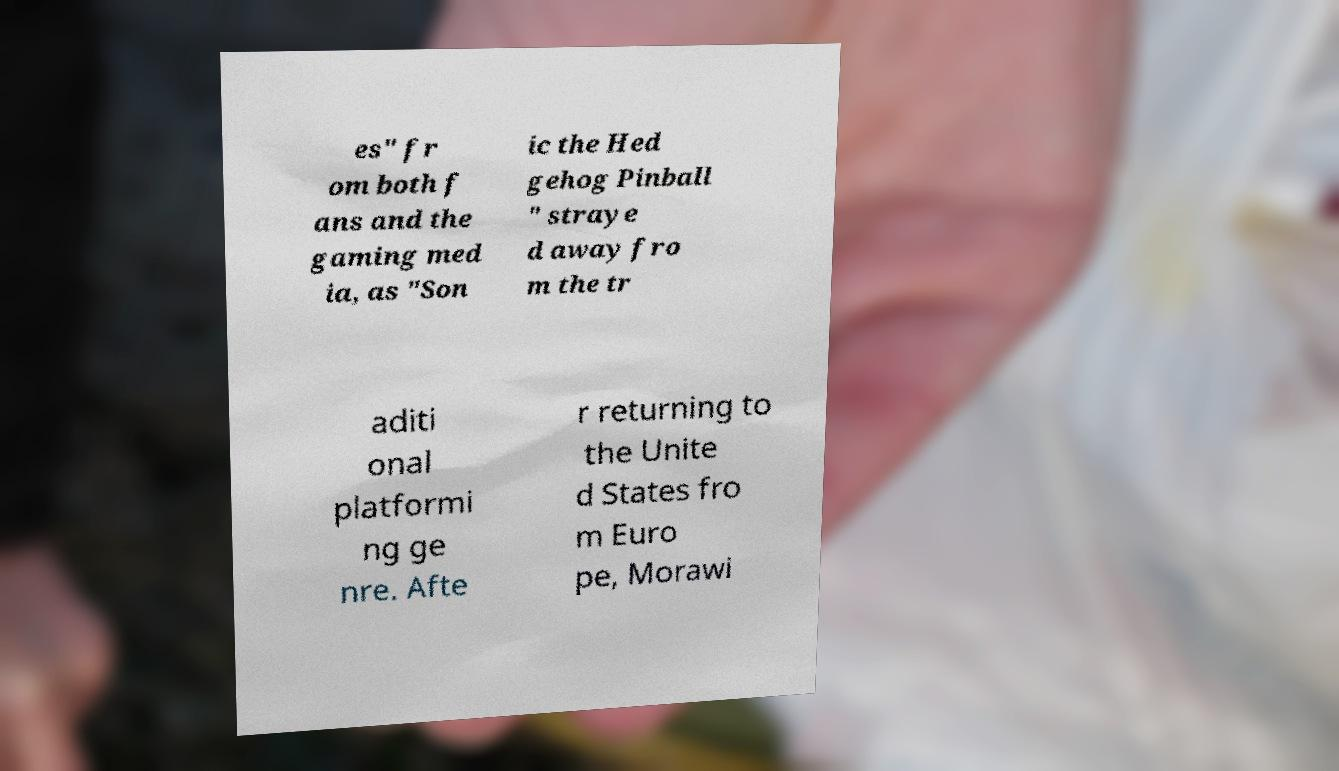There's text embedded in this image that I need extracted. Can you transcribe it verbatim? es" fr om both f ans and the gaming med ia, as "Son ic the Hed gehog Pinball " straye d away fro m the tr aditi onal platformi ng ge nre. Afte r returning to the Unite d States fro m Euro pe, Morawi 